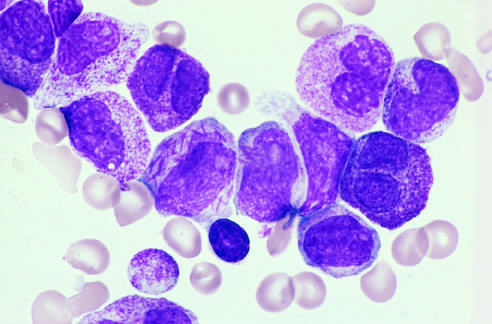what include a cell in the center of the field with multiple needlelike auer rods?
Answer the question using a single word or phrase. Other characteristic findings 